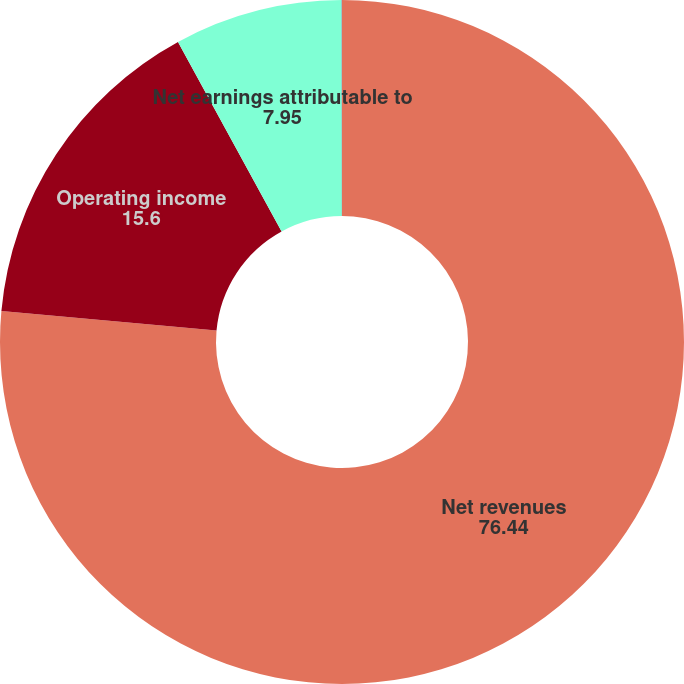Convert chart to OTSL. <chart><loc_0><loc_0><loc_500><loc_500><pie_chart><fcel>Net revenues<fcel>Operating income<fcel>Net earnings attributable to<fcel>EPS - diluted<nl><fcel>76.44%<fcel>15.6%<fcel>7.95%<fcel>0.01%<nl></chart> 